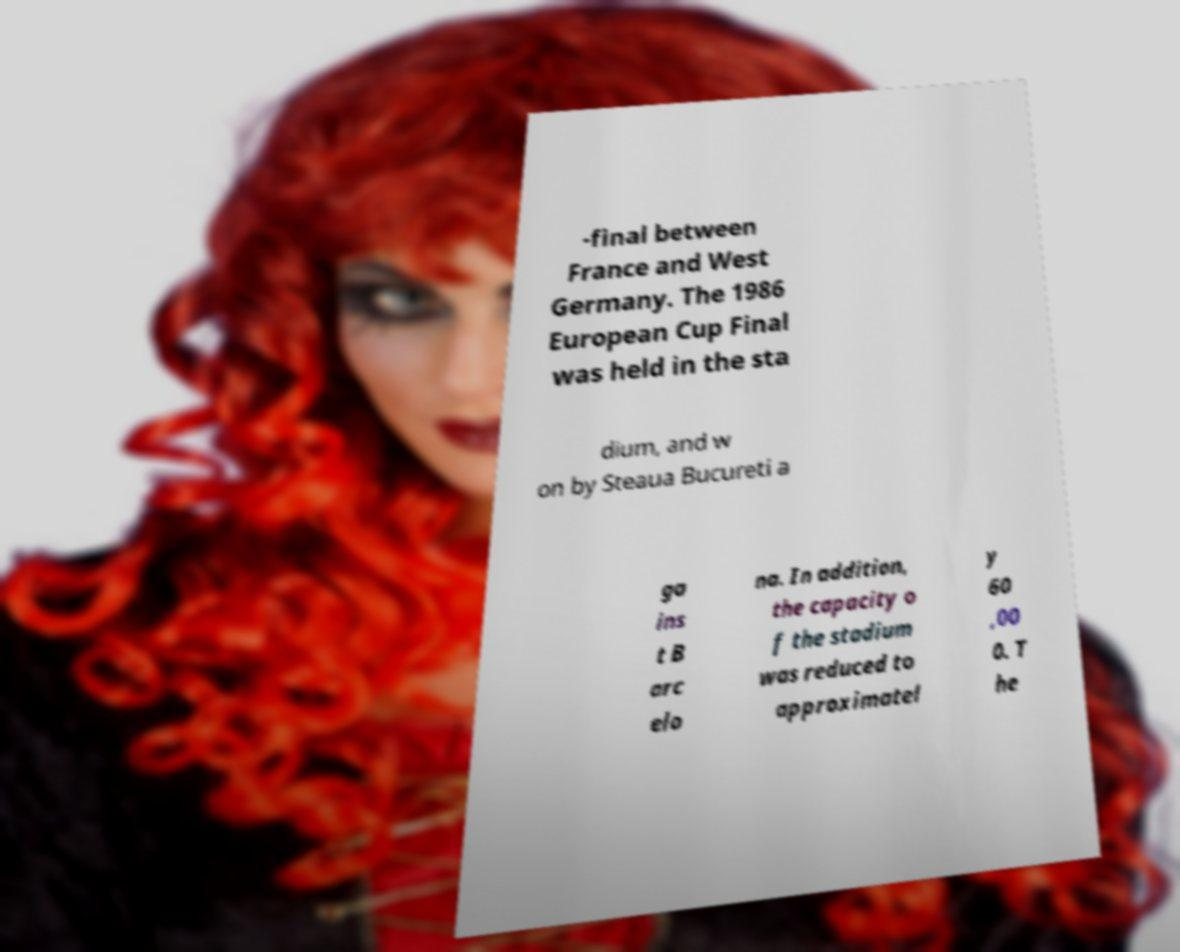Could you assist in decoding the text presented in this image and type it out clearly? -final between France and West Germany. The 1986 European Cup Final was held in the sta dium, and w on by Steaua Bucureti a ga ins t B arc elo na. In addition, the capacity o f the stadium was reduced to approximatel y 60 ,00 0. T he 